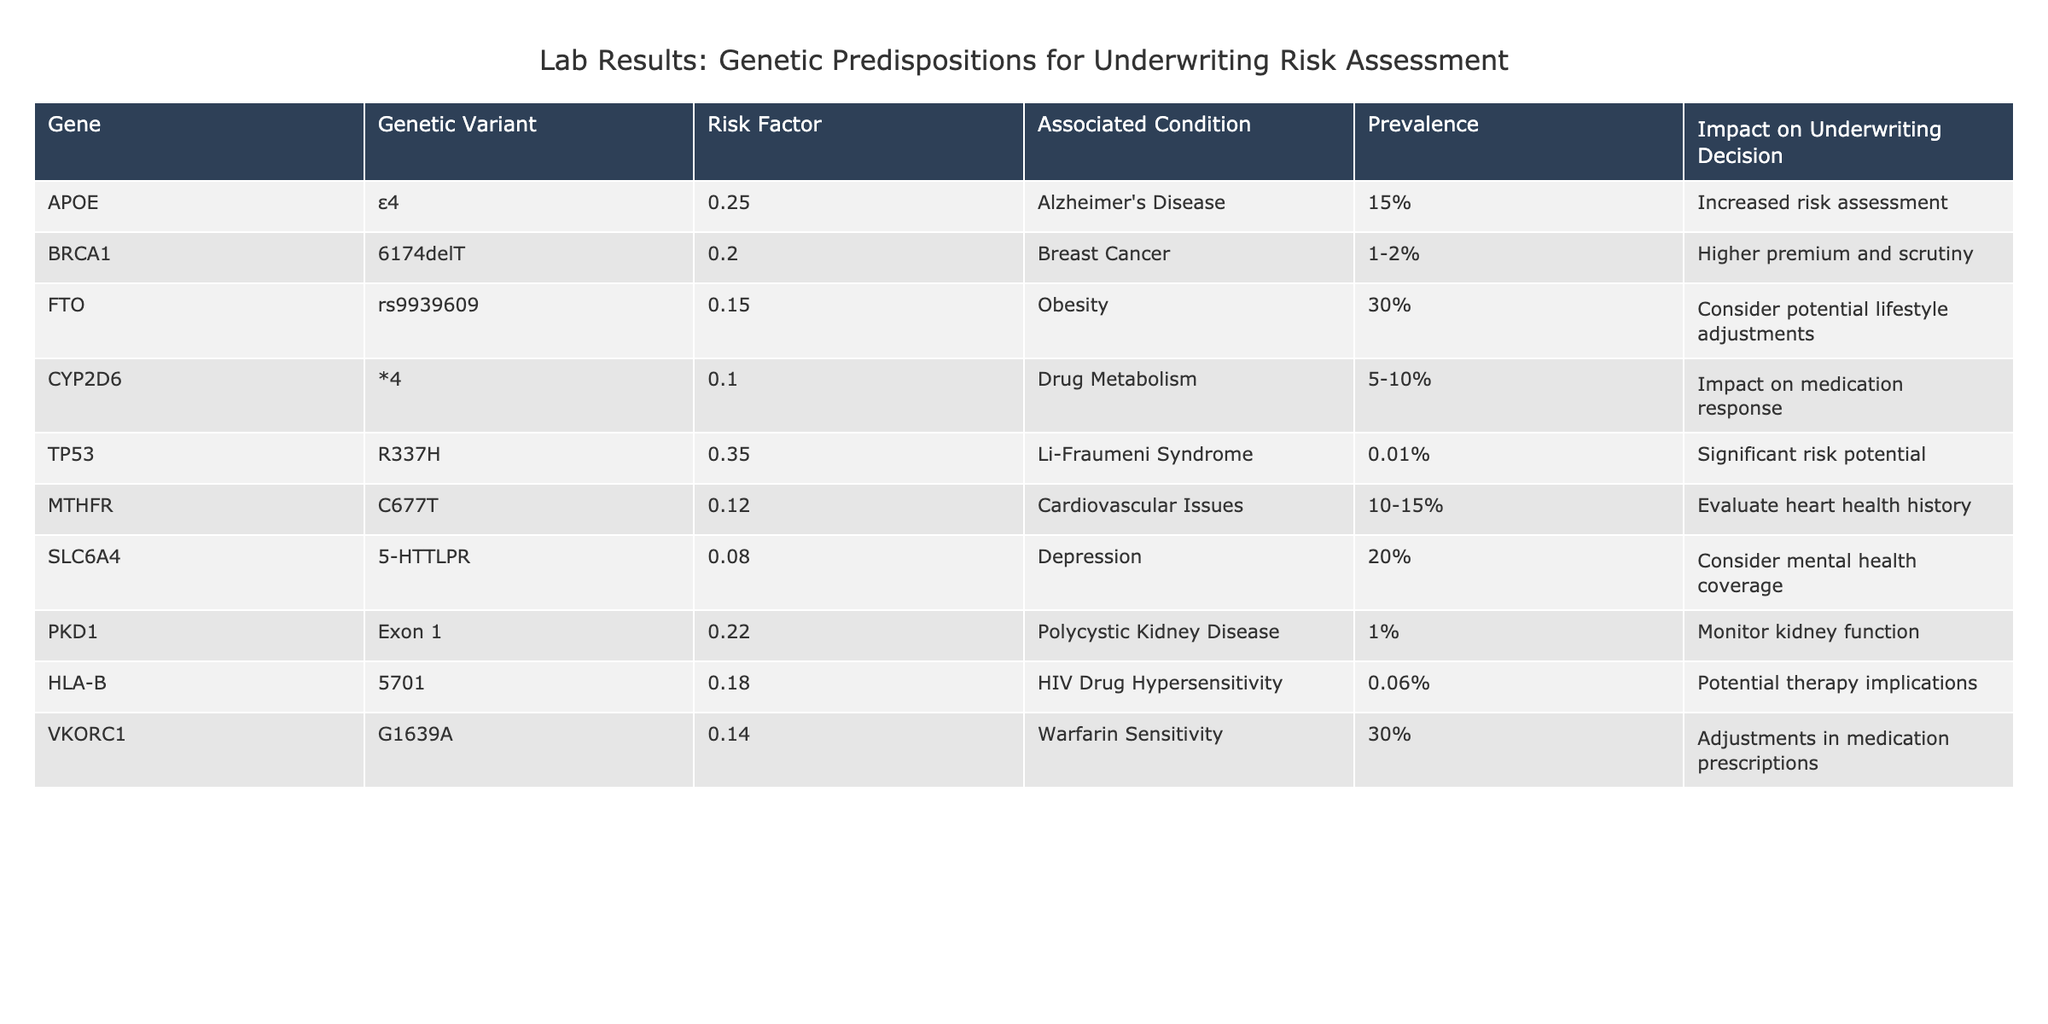What is the risk factor associated with the BRCA1 genetic variant? The table lists the risk factor for the BRCA1 variant as 0.20.
Answer: 0.20 Which condition is associated with the greatest risk factor? The table indicates that the TP53 variant has the highest risk factor of 0.35, associated with Li-Fraumeni Syndrome.
Answer: TP53 (0.35) True or False: The prevalence of the APOE ε4 variant is higher than that of the PKD1 variant. The prevalence for the APOE ε4 variant is 15%, while the prevalence for PKD1 is 1%. Since 15% is greater than 1%, the statement is true.
Answer: True What is the prevalence of HLA-B 5701, and how does it compare to VKORC1? The prevalence of HLA-B 5701 is 0.06% and that of VKORC1 is 30%. Comparing these two values, 0.06% is significantly lower than 30%.
Answer: 0.06% (lower than VKORC1) Calculate the average risk factor for the genetic variants listed in the table. To calculate the average, sum the risk factors: 0.25 + 0.20 + 0.15 + 0.10 + 0.35 + 0.12 + 0.08 + 0.22 + 0.18 + 0.14 = 1.60, then divide by the number of variants (10), so the average risk factor is 1.60 / 10 = 0.16.
Answer: 0.16 Which variant has the most significant impact on underwriting decision? Based on the table, the TP53 variant is noted to have 'significant risk potential', indicating it impacts underwriting decisions the most.
Answer: TP53 True or False: The FTO genetic variant has a higher prevalence than the CYP2D6 genetic variant? The prevalence for FTO is 30%, while for CYP2D6 it is 5-10%. Since 30% is greater than 10%, the statement is true.
Answer: True Identify the variant with the lowest risk factor. The SLC6A4 variant has a risk factor of 0.08, which is the lowest among the listed variants.
Answer: SLC6A4 (0.08) What adjustments should be considered for the VKORC1 variant based on the impact on underwriting decisions? The table states that VKORC1 may require adjustments in medication prescriptions due to warfarin sensitivity.
Answer: Adjustments in medication prescriptions 